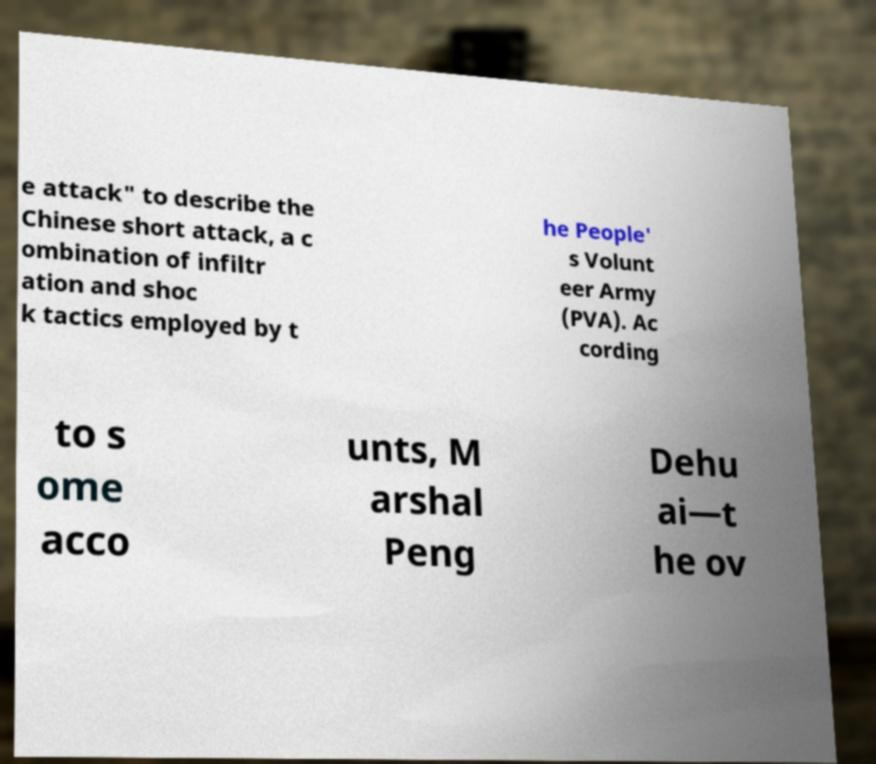There's text embedded in this image that I need extracted. Can you transcribe it verbatim? e attack" to describe the Chinese short attack, a c ombination of infiltr ation and shoc k tactics employed by t he People' s Volunt eer Army (PVA). Ac cording to s ome acco unts, M arshal Peng Dehu ai—t he ov 